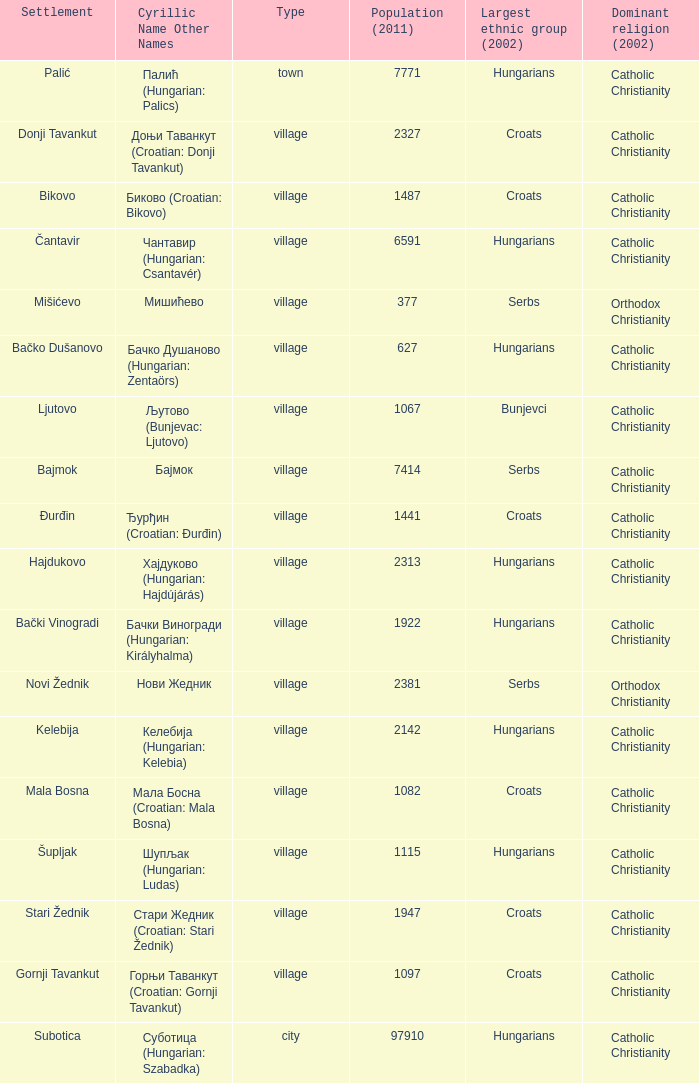What is the population in стари жедник (croatian: stari žednik)? 1947.0. 